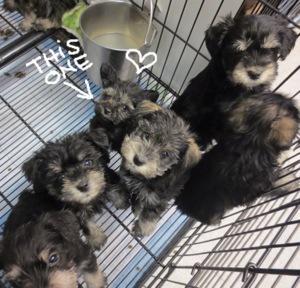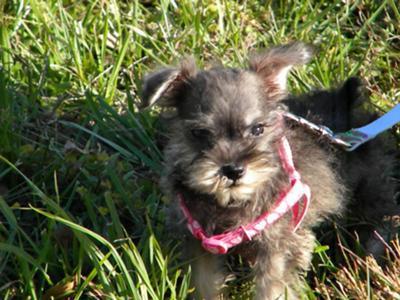The first image is the image on the left, the second image is the image on the right. For the images shown, is this caption "There are exactly four dogs." true? Answer yes or no. No. The first image is the image on the left, the second image is the image on the right. Examine the images to the left and right. Is the description "there is three dogs in the right side image" accurate? Answer yes or no. No. 